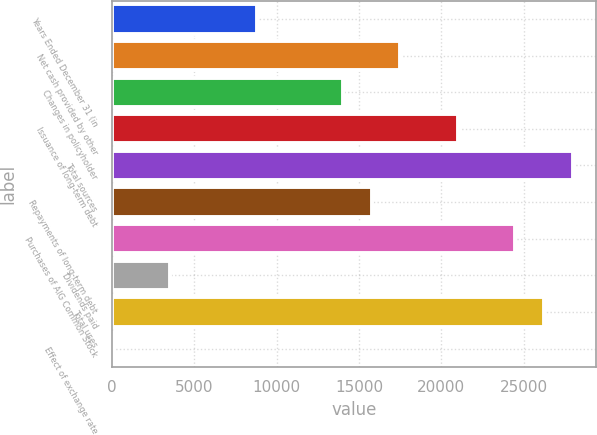Convert chart to OTSL. <chart><loc_0><loc_0><loc_500><loc_500><bar_chart><fcel>Years Ended December 31 (in<fcel>Net cash provided by other<fcel>Changes in policyholder<fcel>Issuance of long-term debt<fcel>Total sources<fcel>Repayments of long-term debt<fcel>Purchases of AIG Common Stock<fcel>Dividends paid<fcel>Total uses<fcel>Effect of exchange rate<nl><fcel>8784.5<fcel>17517<fcel>14024<fcel>21010<fcel>27996<fcel>15770.5<fcel>24503<fcel>3545<fcel>26249.5<fcel>52<nl></chart> 